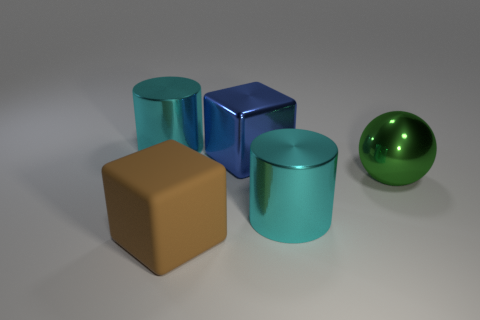Add 5 big blue blocks. How many objects exist? 10 Subtract all blue blocks. How many blocks are left? 1 Subtract all spheres. How many objects are left? 4 Subtract all green spheres. How many brown cylinders are left? 0 Add 3 green metal balls. How many green metal balls exist? 4 Subtract 1 green spheres. How many objects are left? 4 Subtract 2 cubes. How many cubes are left? 0 Subtract all brown balls. Subtract all cyan cylinders. How many balls are left? 1 Subtract all cyan cylinders. Subtract all large green shiny things. How many objects are left? 2 Add 1 blue metal blocks. How many blue metal blocks are left? 2 